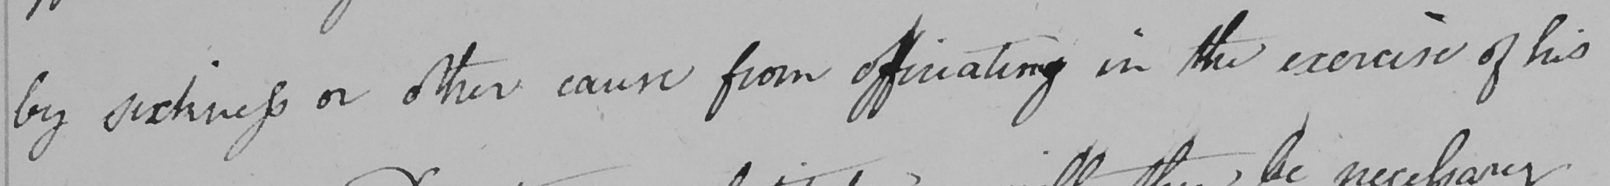Please provide the text content of this handwritten line. by sickness or other cause from officiating in the exercise of his 